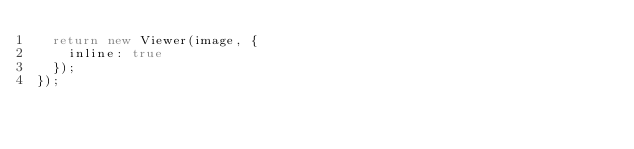<code> <loc_0><loc_0><loc_500><loc_500><_JavaScript_>  return new Viewer(image, {
    inline: true
  });
});
</code> 